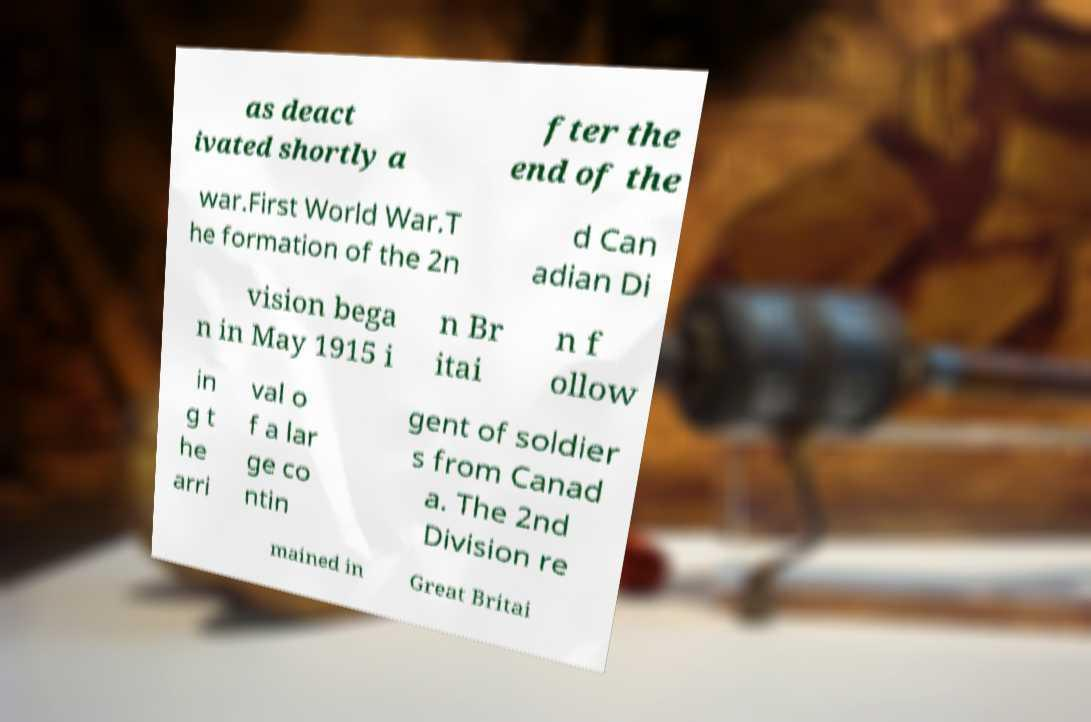Could you extract and type out the text from this image? as deact ivated shortly a fter the end of the war.First World War.T he formation of the 2n d Can adian Di vision bega n in May 1915 i n Br itai n f ollow in g t he arri val o f a lar ge co ntin gent of soldier s from Canad a. The 2nd Division re mained in Great Britai 